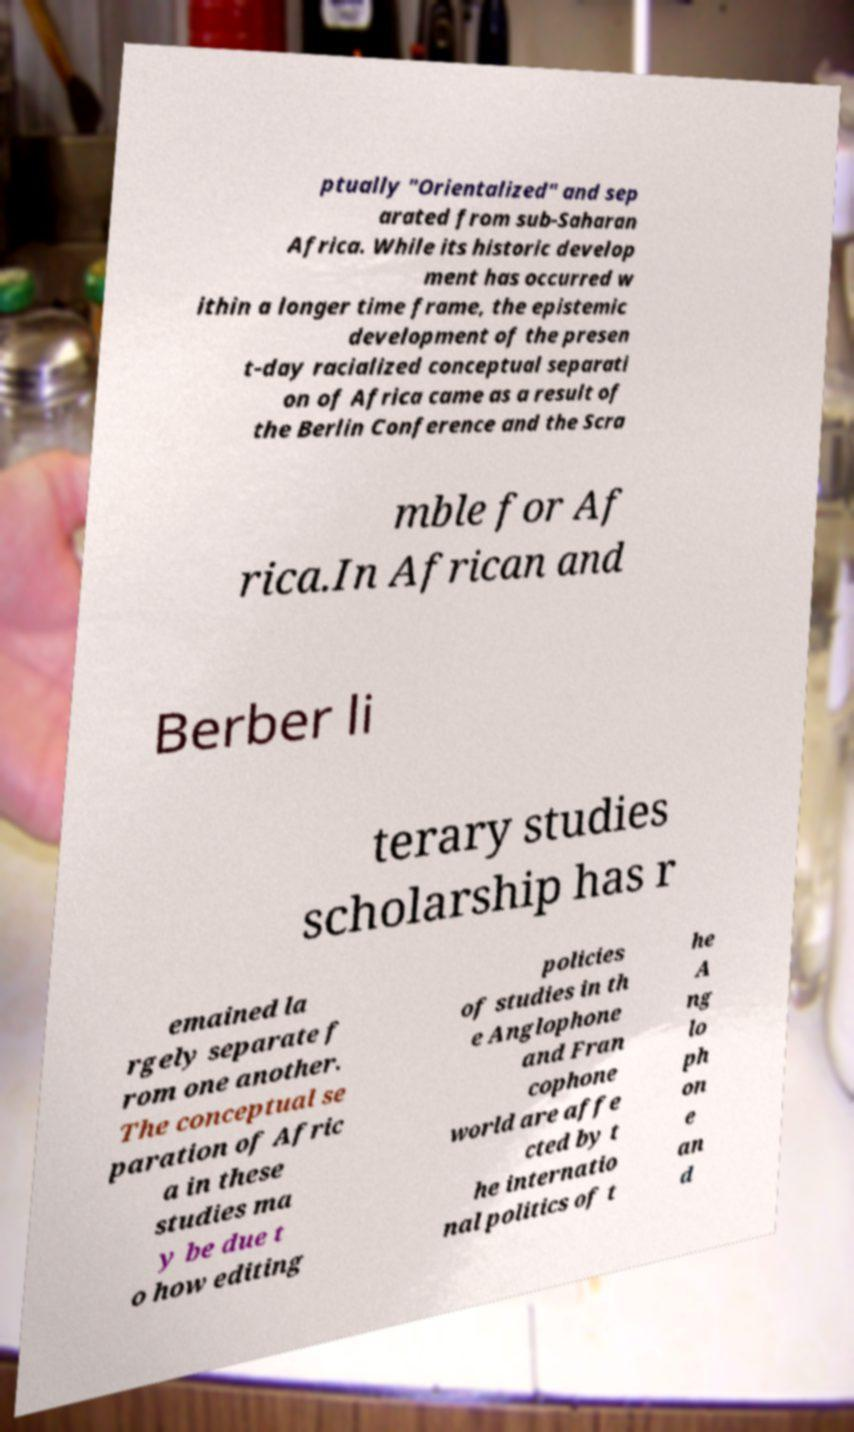Please read and relay the text visible in this image. What does it say? ptually "Orientalized" and sep arated from sub-Saharan Africa. While its historic develop ment has occurred w ithin a longer time frame, the epistemic development of the presen t-day racialized conceptual separati on of Africa came as a result of the Berlin Conference and the Scra mble for Af rica.In African and Berber li terary studies scholarship has r emained la rgely separate f rom one another. The conceptual se paration of Afric a in these studies ma y be due t o how editing policies of studies in th e Anglophone and Fran cophone world are affe cted by t he internatio nal politics of t he A ng lo ph on e an d 